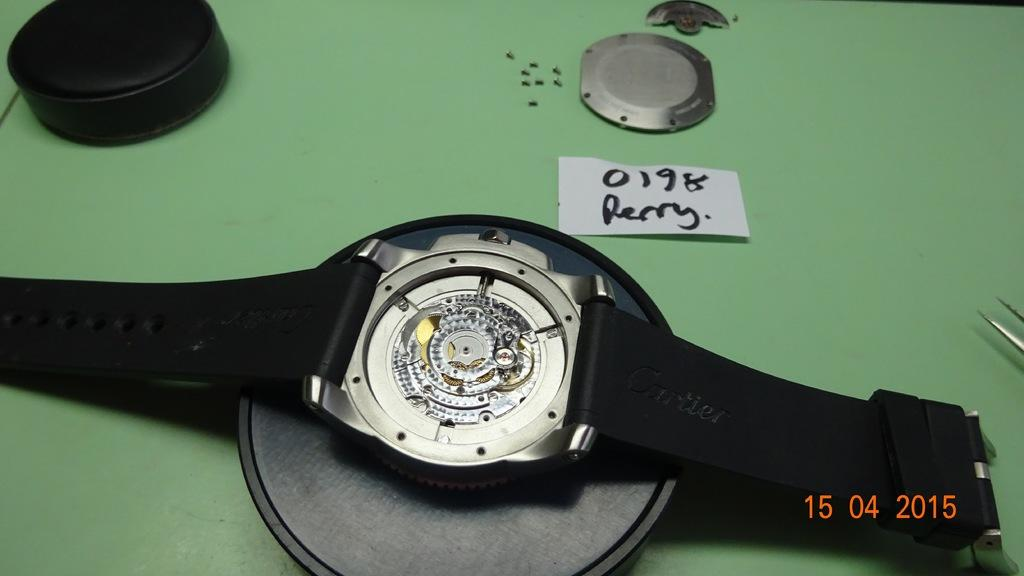<image>
Render a clear and concise summary of the photo. A watch, open from the back with a piece of paper that says 0198 Perry on it. 